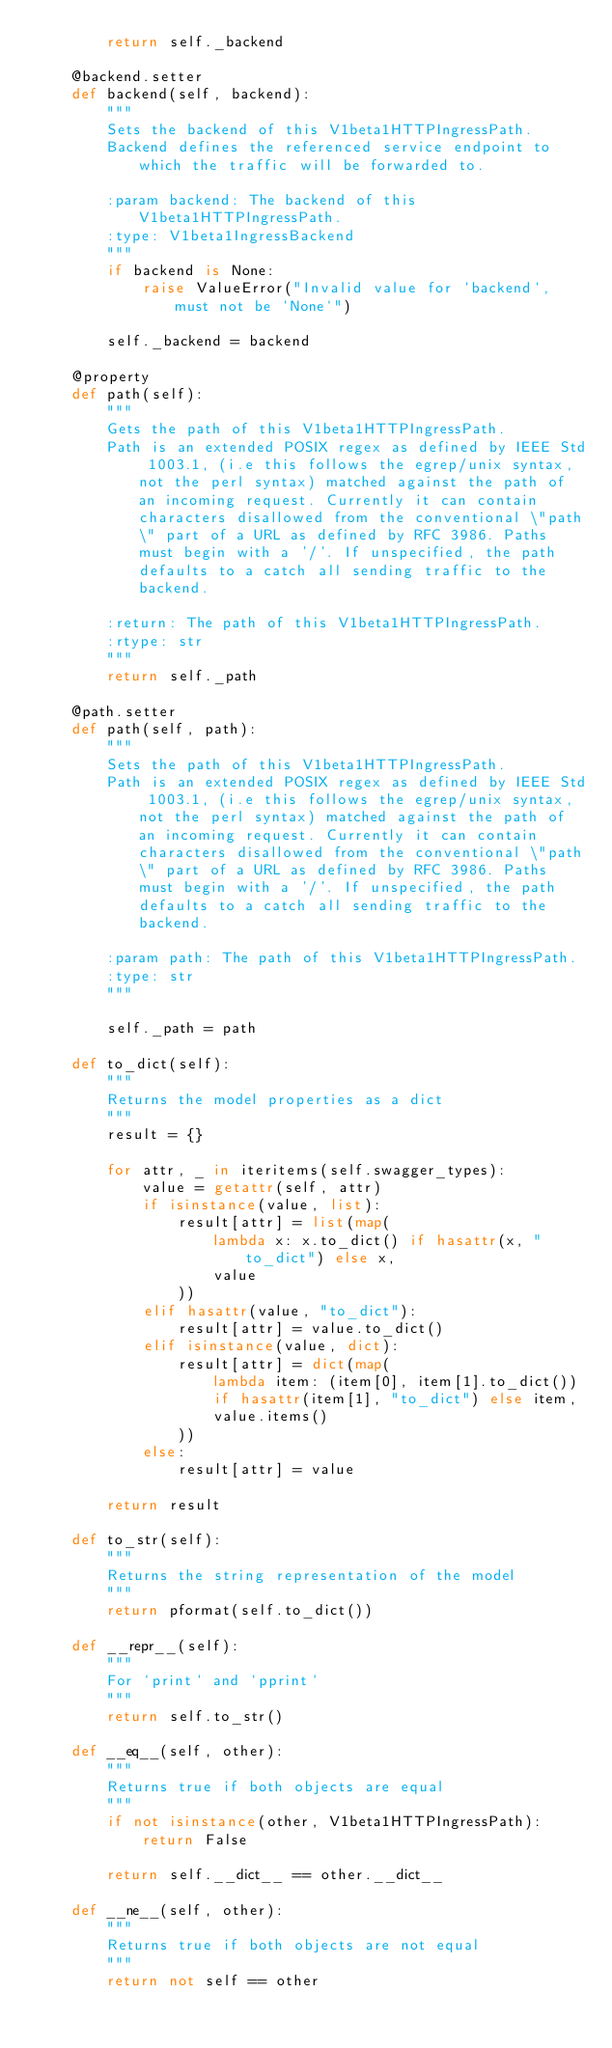Convert code to text. <code><loc_0><loc_0><loc_500><loc_500><_Python_>        return self._backend

    @backend.setter
    def backend(self, backend):
        """
        Sets the backend of this V1beta1HTTPIngressPath.
        Backend defines the referenced service endpoint to which the traffic will be forwarded to.

        :param backend: The backend of this V1beta1HTTPIngressPath.
        :type: V1beta1IngressBackend
        """
        if backend is None:
            raise ValueError("Invalid value for `backend`, must not be `None`")

        self._backend = backend

    @property
    def path(self):
        """
        Gets the path of this V1beta1HTTPIngressPath.
        Path is an extended POSIX regex as defined by IEEE Std 1003.1, (i.e this follows the egrep/unix syntax, not the perl syntax) matched against the path of an incoming request. Currently it can contain characters disallowed from the conventional \"path\" part of a URL as defined by RFC 3986. Paths must begin with a '/'. If unspecified, the path defaults to a catch all sending traffic to the backend.

        :return: The path of this V1beta1HTTPIngressPath.
        :rtype: str
        """
        return self._path

    @path.setter
    def path(self, path):
        """
        Sets the path of this V1beta1HTTPIngressPath.
        Path is an extended POSIX regex as defined by IEEE Std 1003.1, (i.e this follows the egrep/unix syntax, not the perl syntax) matched against the path of an incoming request. Currently it can contain characters disallowed from the conventional \"path\" part of a URL as defined by RFC 3986. Paths must begin with a '/'. If unspecified, the path defaults to a catch all sending traffic to the backend.

        :param path: The path of this V1beta1HTTPIngressPath.
        :type: str
        """

        self._path = path

    def to_dict(self):
        """
        Returns the model properties as a dict
        """
        result = {}

        for attr, _ in iteritems(self.swagger_types):
            value = getattr(self, attr)
            if isinstance(value, list):
                result[attr] = list(map(
                    lambda x: x.to_dict() if hasattr(x, "to_dict") else x,
                    value
                ))
            elif hasattr(value, "to_dict"):
                result[attr] = value.to_dict()
            elif isinstance(value, dict):
                result[attr] = dict(map(
                    lambda item: (item[0], item[1].to_dict())
                    if hasattr(item[1], "to_dict") else item,
                    value.items()
                ))
            else:
                result[attr] = value

        return result

    def to_str(self):
        """
        Returns the string representation of the model
        """
        return pformat(self.to_dict())

    def __repr__(self):
        """
        For `print` and `pprint`
        """
        return self.to_str()

    def __eq__(self, other):
        """
        Returns true if both objects are equal
        """
        if not isinstance(other, V1beta1HTTPIngressPath):
            return False

        return self.__dict__ == other.__dict__

    def __ne__(self, other):
        """
        Returns true if both objects are not equal
        """
        return not self == other
</code> 